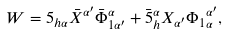Convert formula to latex. <formula><loc_0><loc_0><loc_500><loc_500>W = 5 _ { h \alpha } \bar { X } ^ { \alpha ^ { \prime } } \bar { \Phi } _ { 1 \alpha ^ { \prime } } ^ { \alpha } + \bar { 5 } _ { h } ^ { \alpha } X _ { \alpha ^ { \prime } } { \Phi _ { 1 } } _ { \alpha } ^ { \alpha ^ { \prime } } ,</formula> 